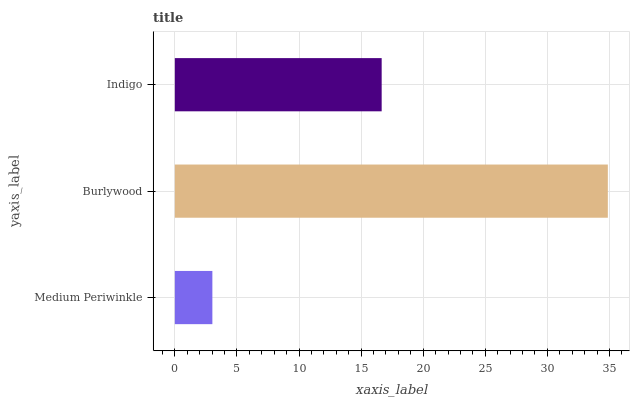Is Medium Periwinkle the minimum?
Answer yes or no. Yes. Is Burlywood the maximum?
Answer yes or no. Yes. Is Indigo the minimum?
Answer yes or no. No. Is Indigo the maximum?
Answer yes or no. No. Is Burlywood greater than Indigo?
Answer yes or no. Yes. Is Indigo less than Burlywood?
Answer yes or no. Yes. Is Indigo greater than Burlywood?
Answer yes or no. No. Is Burlywood less than Indigo?
Answer yes or no. No. Is Indigo the high median?
Answer yes or no. Yes. Is Indigo the low median?
Answer yes or no. Yes. Is Medium Periwinkle the high median?
Answer yes or no. No. Is Medium Periwinkle the low median?
Answer yes or no. No. 